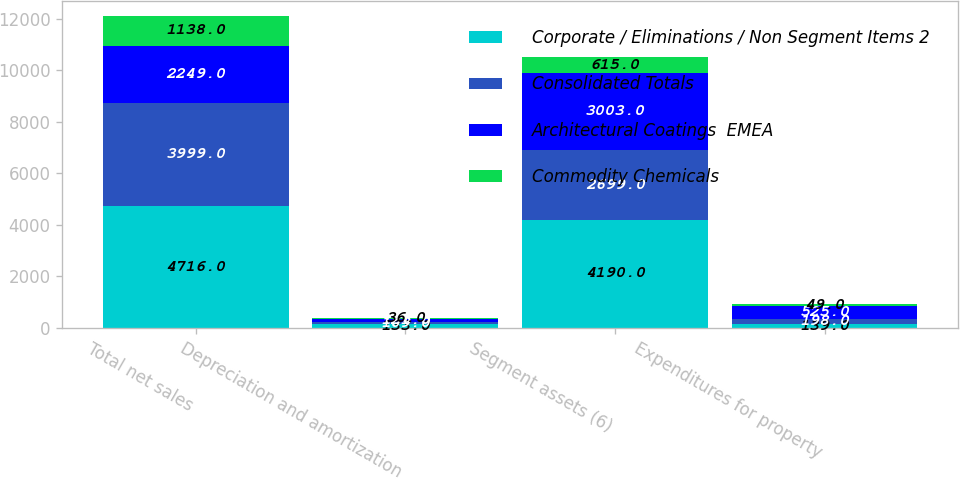<chart> <loc_0><loc_0><loc_500><loc_500><stacked_bar_chart><ecel><fcel>Total net sales<fcel>Depreciation and amortization<fcel>Segment assets (6)<fcel>Expenditures for property<nl><fcel>Corporate / Eliminations / Non Segment Items 2<fcel>4716<fcel>133<fcel>4190<fcel>139<nl><fcel>Consolidated Totals<fcel>3999<fcel>109<fcel>2699<fcel>198<nl><fcel>Architectural Coatings  EMEA<fcel>2249<fcel>121<fcel>3003<fcel>525<nl><fcel>Commodity Chemicals<fcel>1138<fcel>36<fcel>615<fcel>49<nl></chart> 